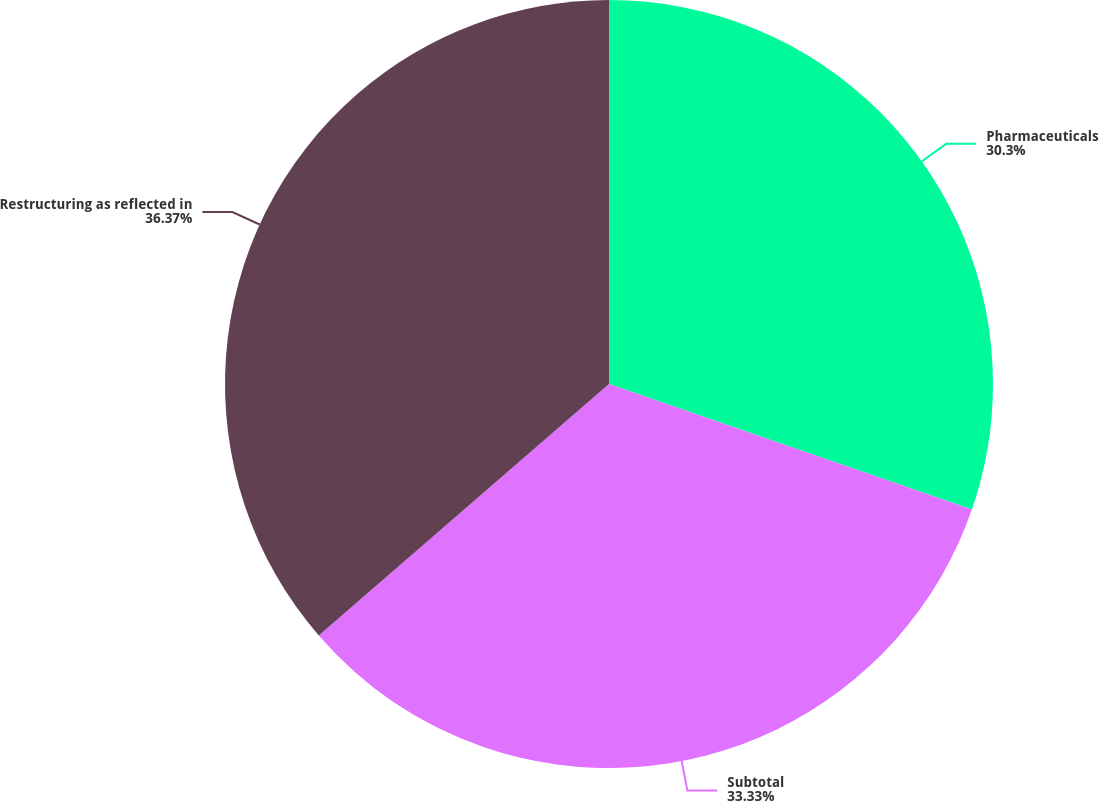Convert chart to OTSL. <chart><loc_0><loc_0><loc_500><loc_500><pie_chart><fcel>Pharmaceuticals<fcel>Subtotal<fcel>Restructuring as reflected in<nl><fcel>30.3%<fcel>33.33%<fcel>36.36%<nl></chart> 